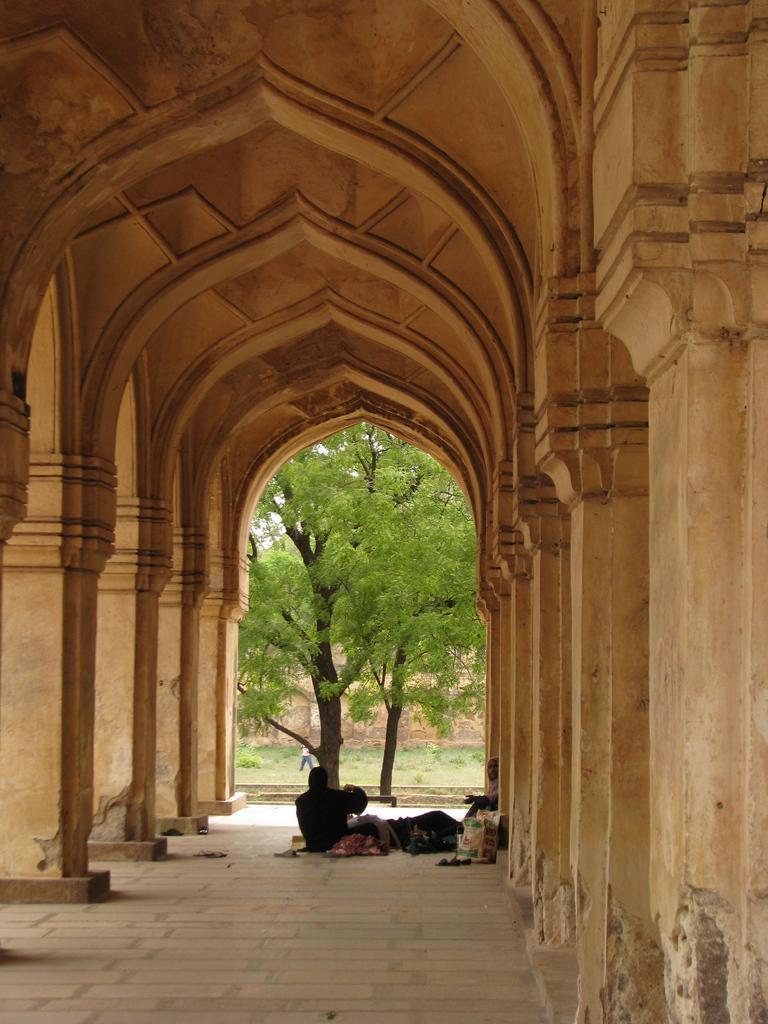Can you describe this image briefly? There are some pillars on the left side of this image and right side of this image as well. There are some trees in the middle of this image. There are some persons are at the bottom of this image. 